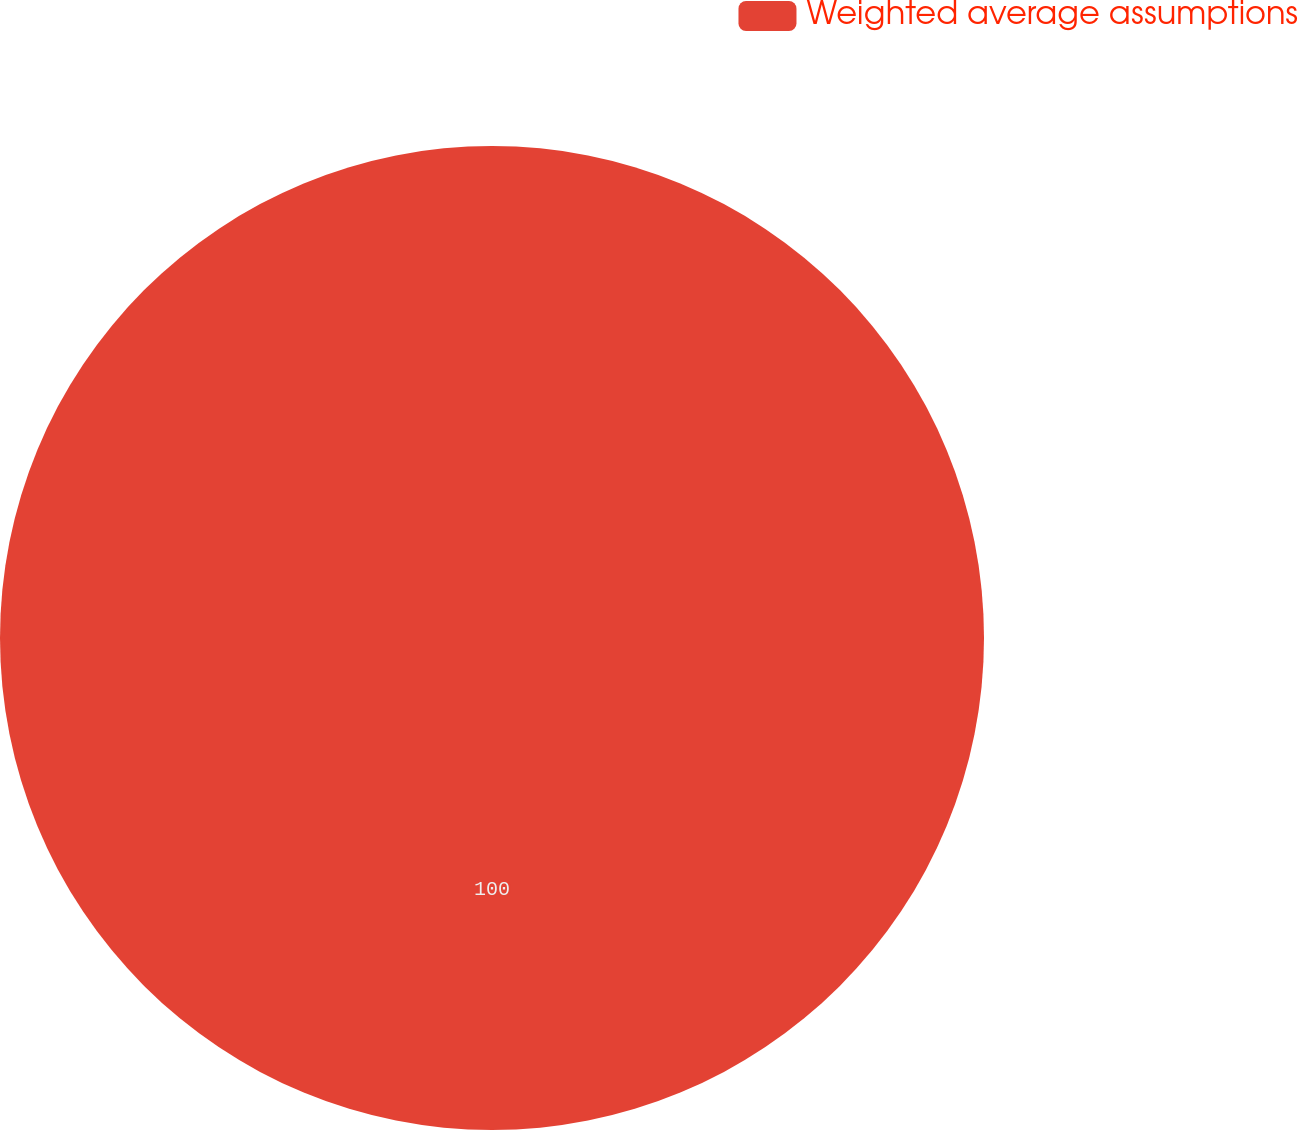Convert chart to OTSL. <chart><loc_0><loc_0><loc_500><loc_500><pie_chart><fcel>Weighted average assumptions<nl><fcel>100.0%<nl></chart> 